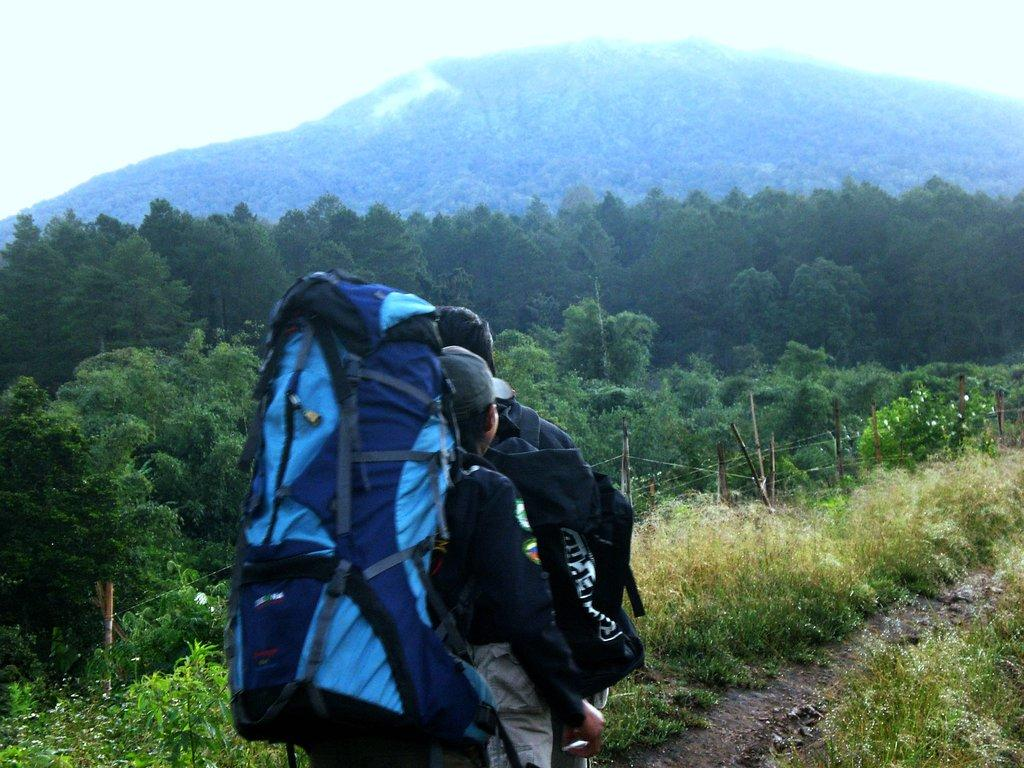What is the main subject in the foreground of the image? There is a person in the foreground of the image. What is the person wearing in the image? The person is wearing a bag. What can be seen in the background of the image? There are trees, hills, and fog visible in the background of the image. What type of tin can be seen in the image? There is no tin present in the image. Does the person in the image have a cough? There is no indication of the person's health or any cough in the image. 